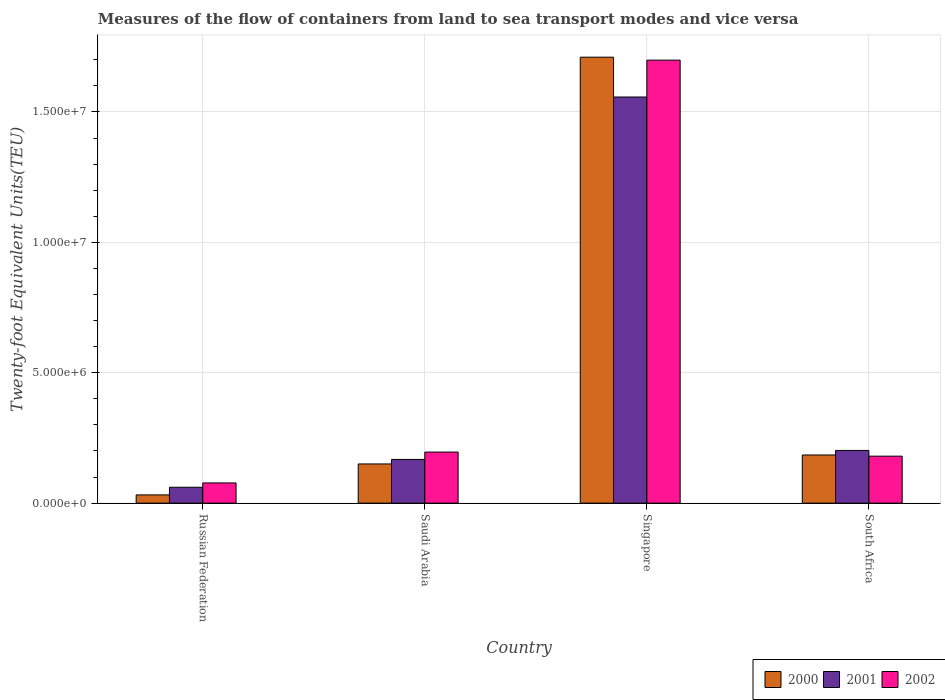Are the number of bars per tick equal to the number of legend labels?
Give a very brief answer. Yes. Are the number of bars on each tick of the X-axis equal?
Your response must be concise. Yes. What is the label of the 3rd group of bars from the left?
Make the answer very short. Singapore. In how many cases, is the number of bars for a given country not equal to the number of legend labels?
Ensure brevity in your answer.  0. What is the container port traffic in 2000 in Russian Federation?
Offer a very short reply. 3.16e+05. Across all countries, what is the maximum container port traffic in 2000?
Keep it short and to the point. 1.71e+07. Across all countries, what is the minimum container port traffic in 2000?
Offer a terse response. 3.16e+05. In which country was the container port traffic in 2002 maximum?
Your answer should be very brief. Singapore. In which country was the container port traffic in 2002 minimum?
Your answer should be very brief. Russian Federation. What is the total container port traffic in 2002 in the graph?
Give a very brief answer. 2.15e+07. What is the difference between the container port traffic in 2002 in Singapore and that in South Africa?
Offer a terse response. 1.52e+07. What is the difference between the container port traffic in 2000 in Russian Federation and the container port traffic in 2002 in South Africa?
Make the answer very short. -1.49e+06. What is the average container port traffic in 2000 per country?
Provide a succinct answer. 5.19e+06. What is the difference between the container port traffic of/in 2002 and container port traffic of/in 2000 in Russian Federation?
Provide a short and direct response. 4.59e+05. In how many countries, is the container port traffic in 2001 greater than 12000000 TEU?
Ensure brevity in your answer.  1. What is the ratio of the container port traffic in 2002 in Russian Federation to that in Singapore?
Give a very brief answer. 0.05. What is the difference between the highest and the second highest container port traffic in 2002?
Provide a short and direct response. -1.50e+07. What is the difference between the highest and the lowest container port traffic in 2002?
Your answer should be very brief. 1.62e+07. What does the 1st bar from the right in Singapore represents?
Your answer should be very brief. 2002. Is it the case that in every country, the sum of the container port traffic in 2001 and container port traffic in 2000 is greater than the container port traffic in 2002?
Provide a succinct answer. Yes. Are all the bars in the graph horizontal?
Offer a very short reply. No. How many countries are there in the graph?
Offer a terse response. 4. Does the graph contain any zero values?
Your answer should be very brief. No. Does the graph contain grids?
Provide a succinct answer. Yes. Where does the legend appear in the graph?
Your response must be concise. Bottom right. How are the legend labels stacked?
Ensure brevity in your answer.  Horizontal. What is the title of the graph?
Make the answer very short. Measures of the flow of containers from land to sea transport modes and vice versa. Does "1974" appear as one of the legend labels in the graph?
Give a very brief answer. No. What is the label or title of the X-axis?
Offer a terse response. Country. What is the label or title of the Y-axis?
Your answer should be compact. Twenty-foot Equivalent Units(TEU). What is the Twenty-foot Equivalent Units(TEU) of 2000 in Russian Federation?
Make the answer very short. 3.16e+05. What is the Twenty-foot Equivalent Units(TEU) of 2001 in Russian Federation?
Offer a very short reply. 6.09e+05. What is the Twenty-foot Equivalent Units(TEU) in 2002 in Russian Federation?
Make the answer very short. 7.75e+05. What is the Twenty-foot Equivalent Units(TEU) of 2000 in Saudi Arabia?
Your answer should be very brief. 1.50e+06. What is the Twenty-foot Equivalent Units(TEU) in 2001 in Saudi Arabia?
Your answer should be very brief. 1.68e+06. What is the Twenty-foot Equivalent Units(TEU) of 2002 in Saudi Arabia?
Make the answer very short. 1.96e+06. What is the Twenty-foot Equivalent Units(TEU) in 2000 in Singapore?
Your answer should be compact. 1.71e+07. What is the Twenty-foot Equivalent Units(TEU) of 2001 in Singapore?
Make the answer very short. 1.56e+07. What is the Twenty-foot Equivalent Units(TEU) in 2002 in Singapore?
Offer a terse response. 1.70e+07. What is the Twenty-foot Equivalent Units(TEU) in 2000 in South Africa?
Your answer should be compact. 1.85e+06. What is the Twenty-foot Equivalent Units(TEU) in 2001 in South Africa?
Make the answer very short. 2.02e+06. What is the Twenty-foot Equivalent Units(TEU) of 2002 in South Africa?
Make the answer very short. 1.80e+06. Across all countries, what is the maximum Twenty-foot Equivalent Units(TEU) in 2000?
Your answer should be very brief. 1.71e+07. Across all countries, what is the maximum Twenty-foot Equivalent Units(TEU) of 2001?
Keep it short and to the point. 1.56e+07. Across all countries, what is the maximum Twenty-foot Equivalent Units(TEU) in 2002?
Ensure brevity in your answer.  1.70e+07. Across all countries, what is the minimum Twenty-foot Equivalent Units(TEU) of 2000?
Your response must be concise. 3.16e+05. Across all countries, what is the minimum Twenty-foot Equivalent Units(TEU) in 2001?
Provide a succinct answer. 6.09e+05. Across all countries, what is the minimum Twenty-foot Equivalent Units(TEU) in 2002?
Give a very brief answer. 7.75e+05. What is the total Twenty-foot Equivalent Units(TEU) in 2000 in the graph?
Your response must be concise. 2.08e+07. What is the total Twenty-foot Equivalent Units(TEU) in 2001 in the graph?
Offer a terse response. 1.99e+07. What is the total Twenty-foot Equivalent Units(TEU) in 2002 in the graph?
Give a very brief answer. 2.15e+07. What is the difference between the Twenty-foot Equivalent Units(TEU) of 2000 in Russian Federation and that in Saudi Arabia?
Provide a succinct answer. -1.19e+06. What is the difference between the Twenty-foot Equivalent Units(TEU) in 2001 in Russian Federation and that in Saudi Arabia?
Your response must be concise. -1.07e+06. What is the difference between the Twenty-foot Equivalent Units(TEU) in 2002 in Russian Federation and that in Saudi Arabia?
Your answer should be compact. -1.18e+06. What is the difference between the Twenty-foot Equivalent Units(TEU) in 2000 in Russian Federation and that in Singapore?
Your answer should be very brief. -1.68e+07. What is the difference between the Twenty-foot Equivalent Units(TEU) in 2001 in Russian Federation and that in Singapore?
Give a very brief answer. -1.50e+07. What is the difference between the Twenty-foot Equivalent Units(TEU) of 2002 in Russian Federation and that in Singapore?
Your answer should be compact. -1.62e+07. What is the difference between the Twenty-foot Equivalent Units(TEU) in 2000 in Russian Federation and that in South Africa?
Your answer should be very brief. -1.53e+06. What is the difference between the Twenty-foot Equivalent Units(TEU) in 2001 in Russian Federation and that in South Africa?
Provide a succinct answer. -1.41e+06. What is the difference between the Twenty-foot Equivalent Units(TEU) in 2002 in Russian Federation and that in South Africa?
Provide a succinct answer. -1.03e+06. What is the difference between the Twenty-foot Equivalent Units(TEU) in 2000 in Saudi Arabia and that in Singapore?
Make the answer very short. -1.56e+07. What is the difference between the Twenty-foot Equivalent Units(TEU) in 2001 in Saudi Arabia and that in Singapore?
Give a very brief answer. -1.39e+07. What is the difference between the Twenty-foot Equivalent Units(TEU) of 2002 in Saudi Arabia and that in Singapore?
Give a very brief answer. -1.50e+07. What is the difference between the Twenty-foot Equivalent Units(TEU) of 2000 in Saudi Arabia and that in South Africa?
Provide a short and direct response. -3.44e+05. What is the difference between the Twenty-foot Equivalent Units(TEU) of 2001 in Saudi Arabia and that in South Africa?
Keep it short and to the point. -3.44e+05. What is the difference between the Twenty-foot Equivalent Units(TEU) in 2002 in Saudi Arabia and that in South Africa?
Ensure brevity in your answer.  1.57e+05. What is the difference between the Twenty-foot Equivalent Units(TEU) in 2000 in Singapore and that in South Africa?
Provide a short and direct response. 1.53e+07. What is the difference between the Twenty-foot Equivalent Units(TEU) in 2001 in Singapore and that in South Africa?
Offer a very short reply. 1.36e+07. What is the difference between the Twenty-foot Equivalent Units(TEU) in 2002 in Singapore and that in South Africa?
Offer a terse response. 1.52e+07. What is the difference between the Twenty-foot Equivalent Units(TEU) of 2000 in Russian Federation and the Twenty-foot Equivalent Units(TEU) of 2001 in Saudi Arabia?
Your response must be concise. -1.36e+06. What is the difference between the Twenty-foot Equivalent Units(TEU) of 2000 in Russian Federation and the Twenty-foot Equivalent Units(TEU) of 2002 in Saudi Arabia?
Provide a short and direct response. -1.64e+06. What is the difference between the Twenty-foot Equivalent Units(TEU) in 2001 in Russian Federation and the Twenty-foot Equivalent Units(TEU) in 2002 in Saudi Arabia?
Ensure brevity in your answer.  -1.35e+06. What is the difference between the Twenty-foot Equivalent Units(TEU) of 2000 in Russian Federation and the Twenty-foot Equivalent Units(TEU) of 2001 in Singapore?
Your response must be concise. -1.53e+07. What is the difference between the Twenty-foot Equivalent Units(TEU) of 2000 in Russian Federation and the Twenty-foot Equivalent Units(TEU) of 2002 in Singapore?
Ensure brevity in your answer.  -1.67e+07. What is the difference between the Twenty-foot Equivalent Units(TEU) in 2001 in Russian Federation and the Twenty-foot Equivalent Units(TEU) in 2002 in Singapore?
Offer a terse response. -1.64e+07. What is the difference between the Twenty-foot Equivalent Units(TEU) in 2000 in Russian Federation and the Twenty-foot Equivalent Units(TEU) in 2001 in South Africa?
Make the answer very short. -1.70e+06. What is the difference between the Twenty-foot Equivalent Units(TEU) of 2000 in Russian Federation and the Twenty-foot Equivalent Units(TEU) of 2002 in South Africa?
Provide a succinct answer. -1.49e+06. What is the difference between the Twenty-foot Equivalent Units(TEU) of 2001 in Russian Federation and the Twenty-foot Equivalent Units(TEU) of 2002 in South Africa?
Provide a succinct answer. -1.19e+06. What is the difference between the Twenty-foot Equivalent Units(TEU) in 2000 in Saudi Arabia and the Twenty-foot Equivalent Units(TEU) in 2001 in Singapore?
Provide a succinct answer. -1.41e+07. What is the difference between the Twenty-foot Equivalent Units(TEU) of 2000 in Saudi Arabia and the Twenty-foot Equivalent Units(TEU) of 2002 in Singapore?
Your response must be concise. -1.55e+07. What is the difference between the Twenty-foot Equivalent Units(TEU) of 2001 in Saudi Arabia and the Twenty-foot Equivalent Units(TEU) of 2002 in Singapore?
Provide a short and direct response. -1.53e+07. What is the difference between the Twenty-foot Equivalent Units(TEU) in 2000 in Saudi Arabia and the Twenty-foot Equivalent Units(TEU) in 2001 in South Africa?
Ensure brevity in your answer.  -5.18e+05. What is the difference between the Twenty-foot Equivalent Units(TEU) in 2000 in Saudi Arabia and the Twenty-foot Equivalent Units(TEU) in 2002 in South Africa?
Your answer should be very brief. -2.99e+05. What is the difference between the Twenty-foot Equivalent Units(TEU) of 2001 in Saudi Arabia and the Twenty-foot Equivalent Units(TEU) of 2002 in South Africa?
Your answer should be very brief. -1.25e+05. What is the difference between the Twenty-foot Equivalent Units(TEU) of 2000 in Singapore and the Twenty-foot Equivalent Units(TEU) of 2001 in South Africa?
Keep it short and to the point. 1.51e+07. What is the difference between the Twenty-foot Equivalent Units(TEU) in 2000 in Singapore and the Twenty-foot Equivalent Units(TEU) in 2002 in South Africa?
Your response must be concise. 1.53e+07. What is the difference between the Twenty-foot Equivalent Units(TEU) in 2001 in Singapore and the Twenty-foot Equivalent Units(TEU) in 2002 in South Africa?
Offer a very short reply. 1.38e+07. What is the average Twenty-foot Equivalent Units(TEU) of 2000 per country?
Your answer should be very brief. 5.19e+06. What is the average Twenty-foot Equivalent Units(TEU) in 2001 per country?
Your response must be concise. 4.97e+06. What is the average Twenty-foot Equivalent Units(TEU) in 2002 per country?
Your response must be concise. 5.38e+06. What is the difference between the Twenty-foot Equivalent Units(TEU) of 2000 and Twenty-foot Equivalent Units(TEU) of 2001 in Russian Federation?
Your answer should be very brief. -2.93e+05. What is the difference between the Twenty-foot Equivalent Units(TEU) of 2000 and Twenty-foot Equivalent Units(TEU) of 2002 in Russian Federation?
Keep it short and to the point. -4.59e+05. What is the difference between the Twenty-foot Equivalent Units(TEU) of 2001 and Twenty-foot Equivalent Units(TEU) of 2002 in Russian Federation?
Make the answer very short. -1.66e+05. What is the difference between the Twenty-foot Equivalent Units(TEU) of 2000 and Twenty-foot Equivalent Units(TEU) of 2001 in Saudi Arabia?
Ensure brevity in your answer.  -1.74e+05. What is the difference between the Twenty-foot Equivalent Units(TEU) in 2000 and Twenty-foot Equivalent Units(TEU) in 2002 in Saudi Arabia?
Ensure brevity in your answer.  -4.56e+05. What is the difference between the Twenty-foot Equivalent Units(TEU) in 2001 and Twenty-foot Equivalent Units(TEU) in 2002 in Saudi Arabia?
Give a very brief answer. -2.82e+05. What is the difference between the Twenty-foot Equivalent Units(TEU) in 2000 and Twenty-foot Equivalent Units(TEU) in 2001 in Singapore?
Your answer should be very brief. 1.53e+06. What is the difference between the Twenty-foot Equivalent Units(TEU) of 2000 and Twenty-foot Equivalent Units(TEU) of 2002 in Singapore?
Provide a short and direct response. 1.14e+05. What is the difference between the Twenty-foot Equivalent Units(TEU) in 2001 and Twenty-foot Equivalent Units(TEU) in 2002 in Singapore?
Ensure brevity in your answer.  -1.41e+06. What is the difference between the Twenty-foot Equivalent Units(TEU) of 2000 and Twenty-foot Equivalent Units(TEU) of 2001 in South Africa?
Keep it short and to the point. -1.74e+05. What is the difference between the Twenty-foot Equivalent Units(TEU) in 2000 and Twenty-foot Equivalent Units(TEU) in 2002 in South Africa?
Your answer should be compact. 4.53e+04. What is the difference between the Twenty-foot Equivalent Units(TEU) of 2001 and Twenty-foot Equivalent Units(TEU) of 2002 in South Africa?
Ensure brevity in your answer.  2.20e+05. What is the ratio of the Twenty-foot Equivalent Units(TEU) of 2000 in Russian Federation to that in Saudi Arabia?
Your response must be concise. 0.21. What is the ratio of the Twenty-foot Equivalent Units(TEU) in 2001 in Russian Federation to that in Saudi Arabia?
Your answer should be very brief. 0.36. What is the ratio of the Twenty-foot Equivalent Units(TEU) of 2002 in Russian Federation to that in Saudi Arabia?
Ensure brevity in your answer.  0.4. What is the ratio of the Twenty-foot Equivalent Units(TEU) in 2000 in Russian Federation to that in Singapore?
Your answer should be compact. 0.02. What is the ratio of the Twenty-foot Equivalent Units(TEU) of 2001 in Russian Federation to that in Singapore?
Your answer should be very brief. 0.04. What is the ratio of the Twenty-foot Equivalent Units(TEU) in 2002 in Russian Federation to that in Singapore?
Your answer should be compact. 0.05. What is the ratio of the Twenty-foot Equivalent Units(TEU) of 2000 in Russian Federation to that in South Africa?
Give a very brief answer. 0.17. What is the ratio of the Twenty-foot Equivalent Units(TEU) of 2001 in Russian Federation to that in South Africa?
Your answer should be very brief. 0.3. What is the ratio of the Twenty-foot Equivalent Units(TEU) of 2002 in Russian Federation to that in South Africa?
Provide a short and direct response. 0.43. What is the ratio of the Twenty-foot Equivalent Units(TEU) of 2000 in Saudi Arabia to that in Singapore?
Provide a succinct answer. 0.09. What is the ratio of the Twenty-foot Equivalent Units(TEU) in 2001 in Saudi Arabia to that in Singapore?
Provide a short and direct response. 0.11. What is the ratio of the Twenty-foot Equivalent Units(TEU) in 2002 in Saudi Arabia to that in Singapore?
Provide a short and direct response. 0.12. What is the ratio of the Twenty-foot Equivalent Units(TEU) of 2000 in Saudi Arabia to that in South Africa?
Offer a terse response. 0.81. What is the ratio of the Twenty-foot Equivalent Units(TEU) of 2001 in Saudi Arabia to that in South Africa?
Make the answer very short. 0.83. What is the ratio of the Twenty-foot Equivalent Units(TEU) in 2002 in Saudi Arabia to that in South Africa?
Make the answer very short. 1.09. What is the ratio of the Twenty-foot Equivalent Units(TEU) of 2000 in Singapore to that in South Africa?
Your answer should be compact. 9.26. What is the ratio of the Twenty-foot Equivalent Units(TEU) in 2001 in Singapore to that in South Africa?
Offer a very short reply. 7.7. What is the ratio of the Twenty-foot Equivalent Units(TEU) of 2002 in Singapore to that in South Africa?
Your response must be concise. 9.43. What is the difference between the highest and the second highest Twenty-foot Equivalent Units(TEU) of 2000?
Give a very brief answer. 1.53e+07. What is the difference between the highest and the second highest Twenty-foot Equivalent Units(TEU) of 2001?
Offer a very short reply. 1.36e+07. What is the difference between the highest and the second highest Twenty-foot Equivalent Units(TEU) of 2002?
Offer a terse response. 1.50e+07. What is the difference between the highest and the lowest Twenty-foot Equivalent Units(TEU) in 2000?
Ensure brevity in your answer.  1.68e+07. What is the difference between the highest and the lowest Twenty-foot Equivalent Units(TEU) of 2001?
Provide a succinct answer. 1.50e+07. What is the difference between the highest and the lowest Twenty-foot Equivalent Units(TEU) of 2002?
Make the answer very short. 1.62e+07. 